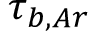Convert formula to latex. <formula><loc_0><loc_0><loc_500><loc_500>\tau _ { b , A r }</formula> 